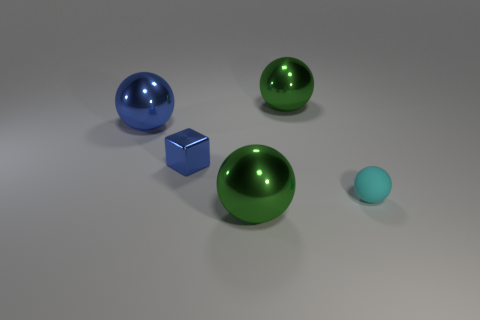What do the different sizes of the objects suggest about their relationship? The varied sizes could imply a sense of depth or perspective, with larger objects possibly being perceived as closer to the viewer. They might also represent a hierarchy or progression in volume, with the tiny ball suggesting a smaller, perhaps lesser, element in the context of the group. 